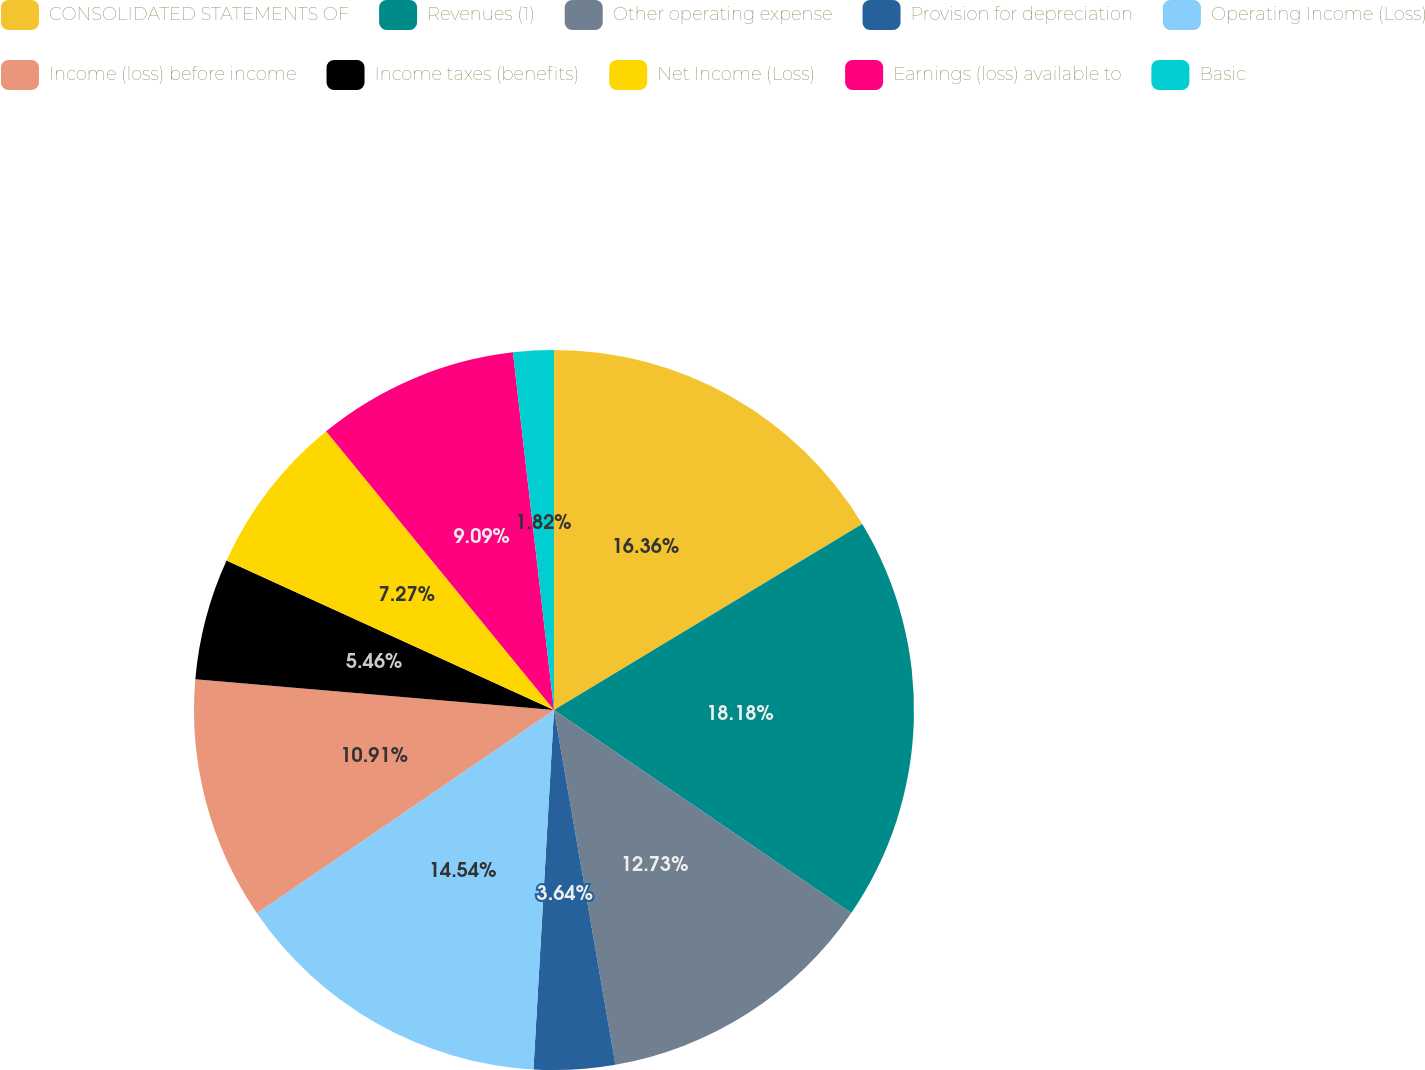<chart> <loc_0><loc_0><loc_500><loc_500><pie_chart><fcel>CONSOLIDATED STATEMENTS OF<fcel>Revenues (1)<fcel>Other operating expense<fcel>Provision for depreciation<fcel>Operating Income (Loss)<fcel>Income (loss) before income<fcel>Income taxes (benefits)<fcel>Net Income (Loss)<fcel>Earnings (loss) available to<fcel>Basic<nl><fcel>16.36%<fcel>18.18%<fcel>12.73%<fcel>3.64%<fcel>14.54%<fcel>10.91%<fcel>5.46%<fcel>7.27%<fcel>9.09%<fcel>1.82%<nl></chart> 